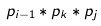Convert formula to latex. <formula><loc_0><loc_0><loc_500><loc_500>p _ { i - 1 } * p _ { k } * p _ { j }</formula> 